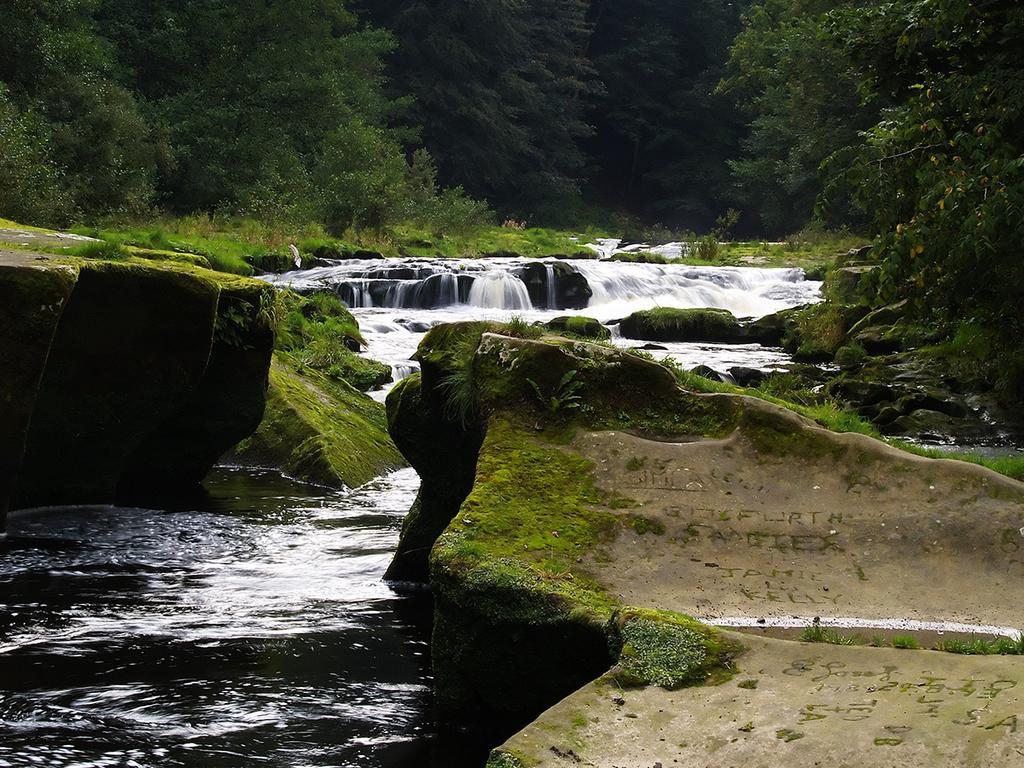Could you give a brief overview of what you see in this image? In this picture, we see the tributary of the river is flowing. Beside that, there are rocks. In the background, there are trees. 